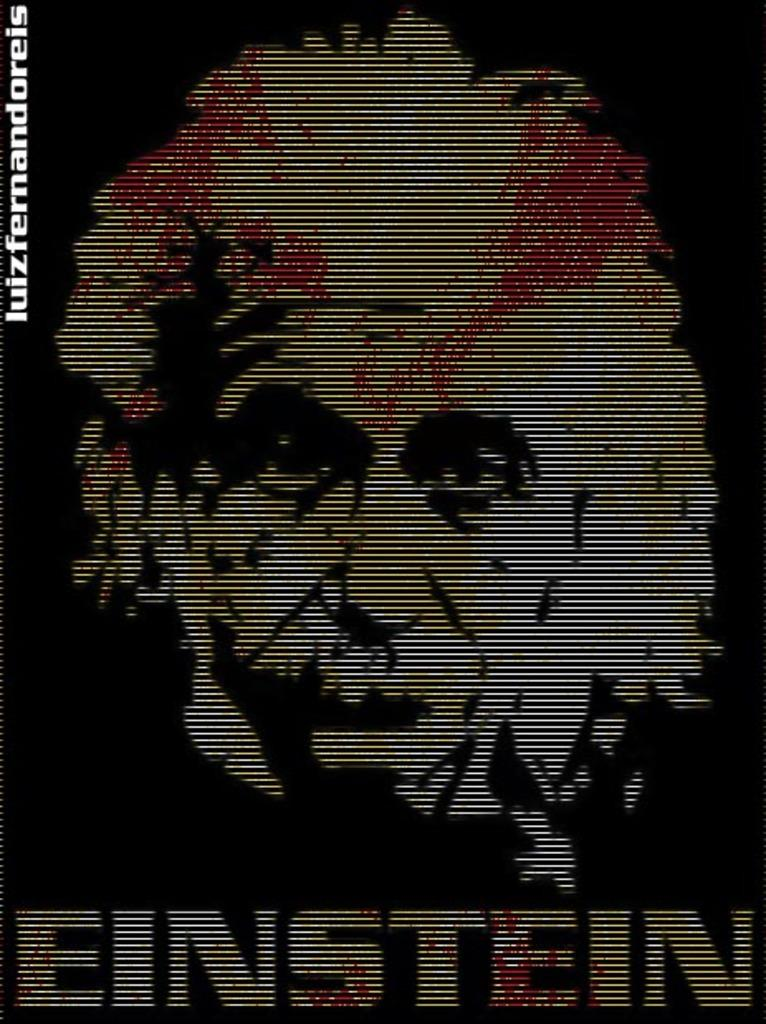Provide a one-sentence caption for the provided image. A computer screen shows an image in black and white with some red of EINSTEIN. 